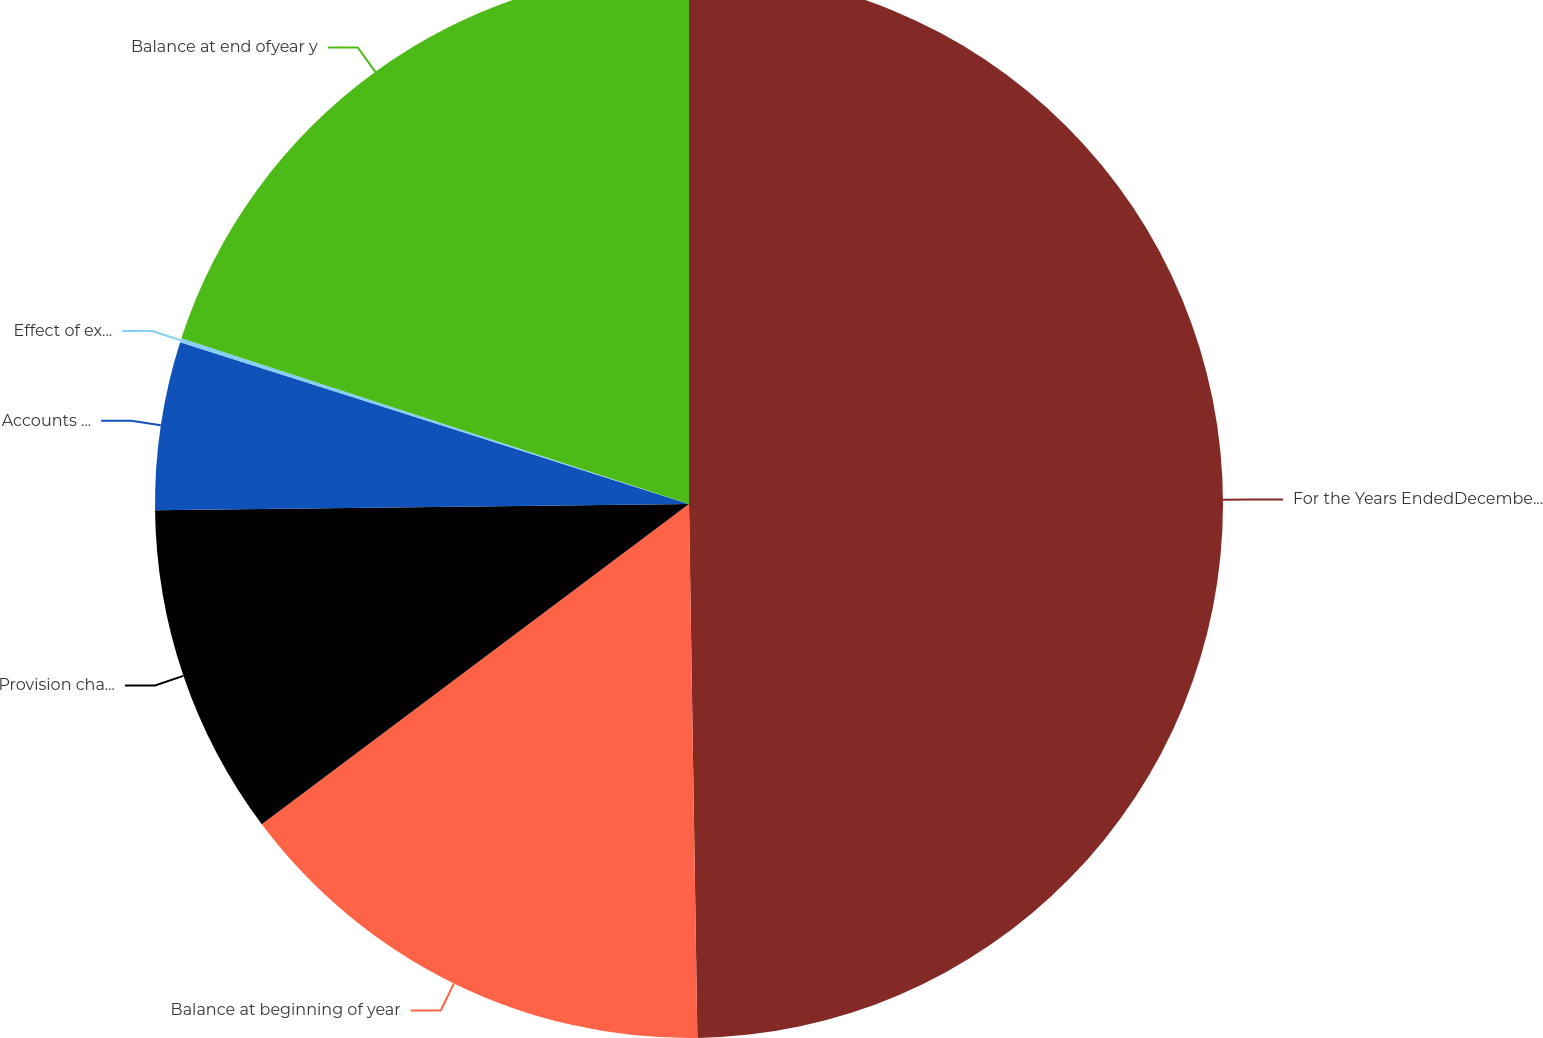<chart> <loc_0><loc_0><loc_500><loc_500><pie_chart><fcel>For the Years EndedDecember 31<fcel>Balance at beginning of year<fcel>Provision charged to<fcel>Accounts written-off net of<fcel>Effect of exchange rate<fcel>Balance at end ofyear y<nl><fcel>49.75%<fcel>15.01%<fcel>10.05%<fcel>5.09%<fcel>0.12%<fcel>19.98%<nl></chart> 